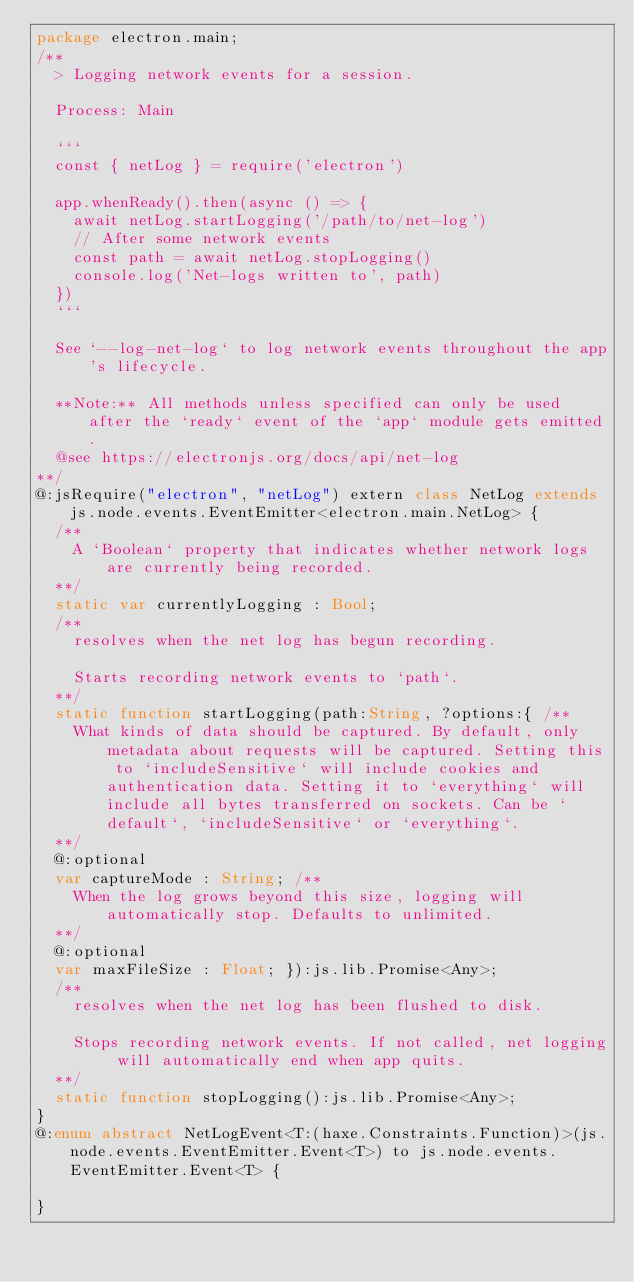Convert code to text. <code><loc_0><loc_0><loc_500><loc_500><_Haxe_>package electron.main;
/**
	> Logging network events for a session.
	
	Process: Main
	
	```
	const { netLog } = require('electron')
	
	app.whenReady().then(async () => {
	  await netLog.startLogging('/path/to/net-log')
	  // After some network events
	  const path = await netLog.stopLogging()
	  console.log('Net-logs written to', path)
	})
	```
	
	See `--log-net-log` to log network events throughout the app's lifecycle.
	
	**Note:** All methods unless specified can only be used after the `ready` event of the `app` module gets emitted.
	@see https://electronjs.org/docs/api/net-log
**/
@:jsRequire("electron", "netLog") extern class NetLog extends js.node.events.EventEmitter<electron.main.NetLog> {
	/**
		A `Boolean` property that indicates whether network logs are currently being recorded.
	**/
	static var currentlyLogging : Bool;
	/**
		resolves when the net log has begun recording.
		
		Starts recording network events to `path`.
	**/
	static function startLogging(path:String, ?options:{ /**
		What kinds of data should be captured. By default, only metadata about requests will be captured. Setting this to `includeSensitive` will include cookies and authentication data. Setting it to `everything` will include all bytes transferred on sockets. Can be `default`, `includeSensitive` or `everything`.
	**/
	@:optional
	var captureMode : String; /**
		When the log grows beyond this size, logging will automatically stop. Defaults to unlimited.
	**/
	@:optional
	var maxFileSize : Float; }):js.lib.Promise<Any>;
	/**
		resolves when the net log has been flushed to disk.
		
		Stops recording network events. If not called, net logging will automatically end when app quits.
	**/
	static function stopLogging():js.lib.Promise<Any>;
}
@:enum abstract NetLogEvent<T:(haxe.Constraints.Function)>(js.node.events.EventEmitter.Event<T>) to js.node.events.EventEmitter.Event<T> {

}
</code> 